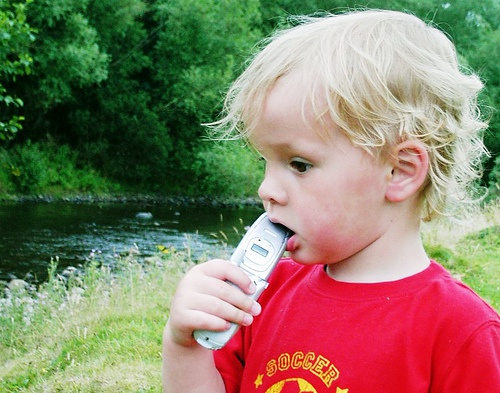Describe the objects in this image and their specific colors. I can see people in green, lightgray, pink, red, and brown tones and cell phone in green, white, lightblue, and darkgray tones in this image. 